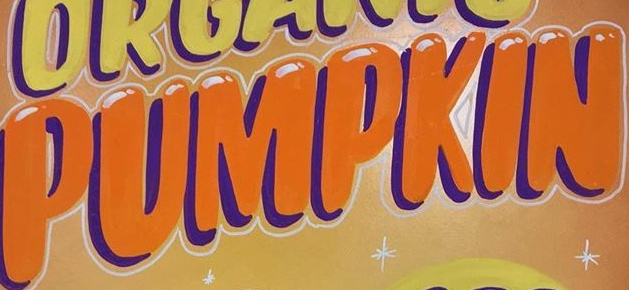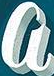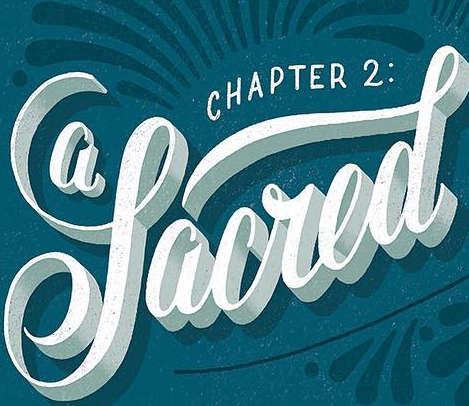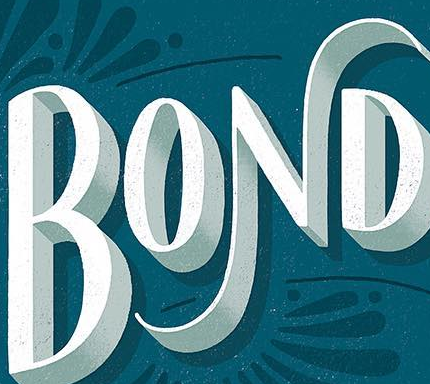What text is displayed in these images sequentially, separated by a semicolon? PUMPKIN; a; Sacred; BOND 